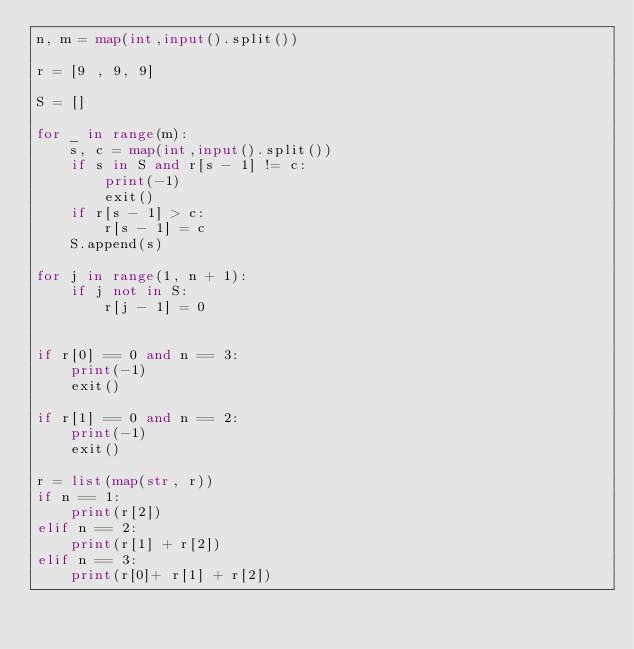Convert code to text. <code><loc_0><loc_0><loc_500><loc_500><_Python_>n, m = map(int,input().split())

r = [9 , 9, 9]

S = []

for _ in range(m):
    s, c = map(int,input().split())
    if s in S and r[s - 1] != c:
        print(-1)
        exit() 
    if r[s - 1] > c:
        r[s - 1] = c
    S.append(s)

for j in range(1, n + 1):
    if j not in S:
        r[j - 1] = 0


if r[0] == 0 and n == 3:
    print(-1)
    exit()

if r[1] == 0 and n == 2:
    print(-1)
    exit()

r = list(map(str, r))
if n == 1:
    print(r[2])
elif n == 2:
    print(r[1] + r[2])
elif n == 3:
    print(r[0]+ r[1] + r[2])
</code> 